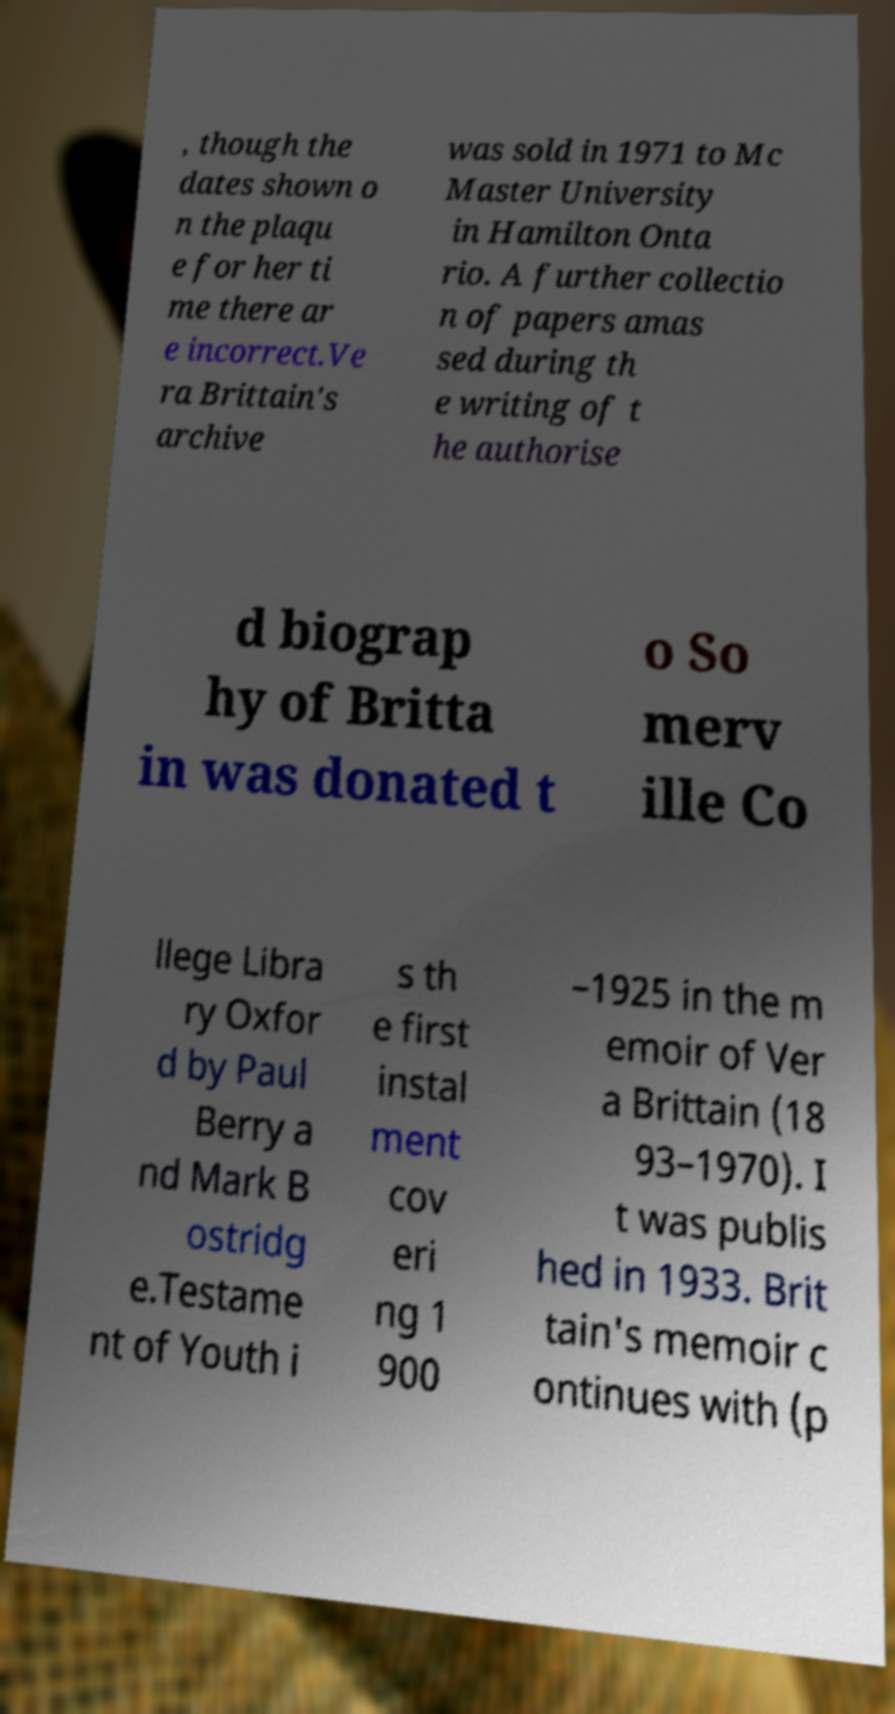I need the written content from this picture converted into text. Can you do that? , though the dates shown o n the plaqu e for her ti me there ar e incorrect.Ve ra Brittain's archive was sold in 1971 to Mc Master University in Hamilton Onta rio. A further collectio n of papers amas sed during th e writing of t he authorise d biograp hy of Britta in was donated t o So merv ille Co llege Libra ry Oxfor d by Paul Berry a nd Mark B ostridg e.Testame nt of Youth i s th e first instal ment cov eri ng 1 900 –1925 in the m emoir of Ver a Brittain (18 93–1970). I t was publis hed in 1933. Brit tain's memoir c ontinues with (p 